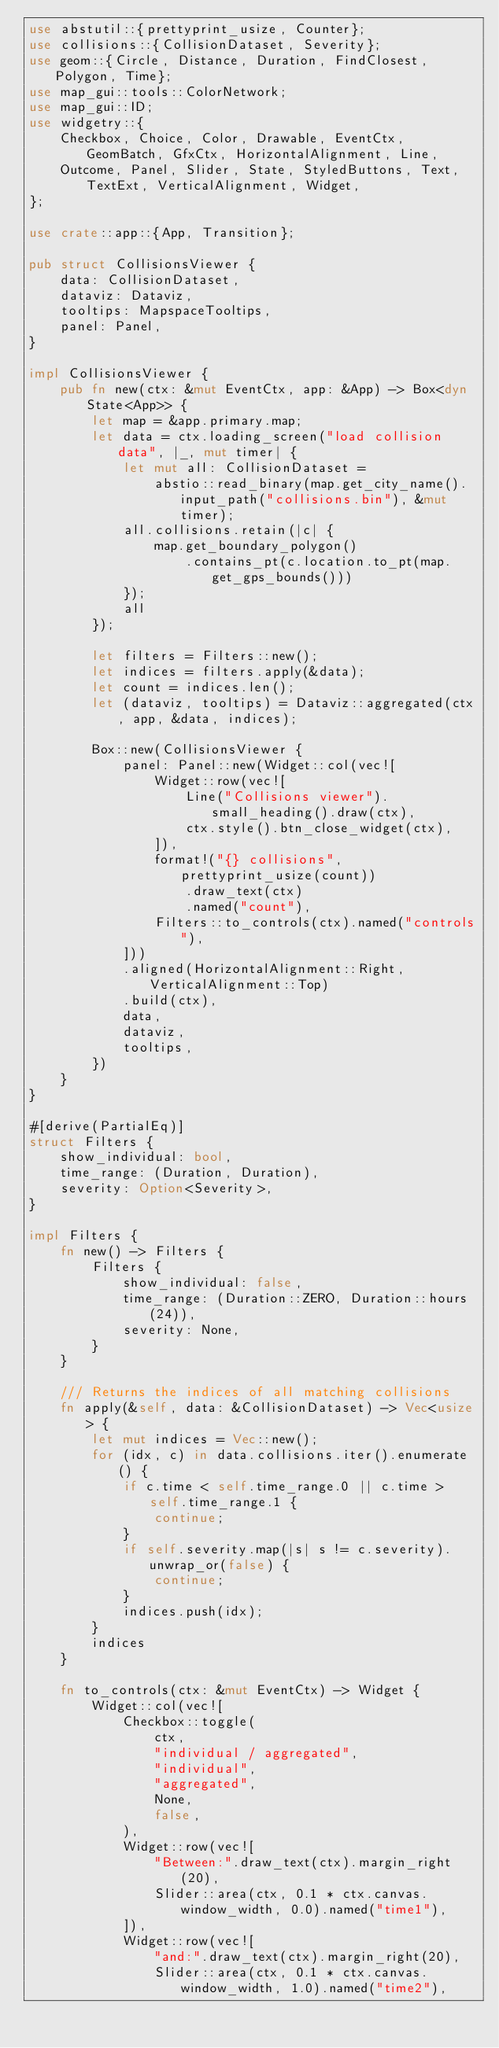<code> <loc_0><loc_0><loc_500><loc_500><_Rust_>use abstutil::{prettyprint_usize, Counter};
use collisions::{CollisionDataset, Severity};
use geom::{Circle, Distance, Duration, FindClosest, Polygon, Time};
use map_gui::tools::ColorNetwork;
use map_gui::ID;
use widgetry::{
    Checkbox, Choice, Color, Drawable, EventCtx, GeomBatch, GfxCtx, HorizontalAlignment, Line,
    Outcome, Panel, Slider, State, StyledButtons, Text, TextExt, VerticalAlignment, Widget,
};

use crate::app::{App, Transition};

pub struct CollisionsViewer {
    data: CollisionDataset,
    dataviz: Dataviz,
    tooltips: MapspaceTooltips,
    panel: Panel,
}

impl CollisionsViewer {
    pub fn new(ctx: &mut EventCtx, app: &App) -> Box<dyn State<App>> {
        let map = &app.primary.map;
        let data = ctx.loading_screen("load collision data", |_, mut timer| {
            let mut all: CollisionDataset =
                abstio::read_binary(map.get_city_name().input_path("collisions.bin"), &mut timer);
            all.collisions.retain(|c| {
                map.get_boundary_polygon()
                    .contains_pt(c.location.to_pt(map.get_gps_bounds()))
            });
            all
        });

        let filters = Filters::new();
        let indices = filters.apply(&data);
        let count = indices.len();
        let (dataviz, tooltips) = Dataviz::aggregated(ctx, app, &data, indices);

        Box::new(CollisionsViewer {
            panel: Panel::new(Widget::col(vec![
                Widget::row(vec![
                    Line("Collisions viewer").small_heading().draw(ctx),
                    ctx.style().btn_close_widget(ctx),
                ]),
                format!("{} collisions", prettyprint_usize(count))
                    .draw_text(ctx)
                    .named("count"),
                Filters::to_controls(ctx).named("controls"),
            ]))
            .aligned(HorizontalAlignment::Right, VerticalAlignment::Top)
            .build(ctx),
            data,
            dataviz,
            tooltips,
        })
    }
}

#[derive(PartialEq)]
struct Filters {
    show_individual: bool,
    time_range: (Duration, Duration),
    severity: Option<Severity>,
}

impl Filters {
    fn new() -> Filters {
        Filters {
            show_individual: false,
            time_range: (Duration::ZERO, Duration::hours(24)),
            severity: None,
        }
    }

    /// Returns the indices of all matching collisions
    fn apply(&self, data: &CollisionDataset) -> Vec<usize> {
        let mut indices = Vec::new();
        for (idx, c) in data.collisions.iter().enumerate() {
            if c.time < self.time_range.0 || c.time > self.time_range.1 {
                continue;
            }
            if self.severity.map(|s| s != c.severity).unwrap_or(false) {
                continue;
            }
            indices.push(idx);
        }
        indices
    }

    fn to_controls(ctx: &mut EventCtx) -> Widget {
        Widget::col(vec![
            Checkbox::toggle(
                ctx,
                "individual / aggregated",
                "individual",
                "aggregated",
                None,
                false,
            ),
            Widget::row(vec![
                "Between:".draw_text(ctx).margin_right(20),
                Slider::area(ctx, 0.1 * ctx.canvas.window_width, 0.0).named("time1"),
            ]),
            Widget::row(vec![
                "and:".draw_text(ctx).margin_right(20),
                Slider::area(ctx, 0.1 * ctx.canvas.window_width, 1.0).named("time2"),</code> 